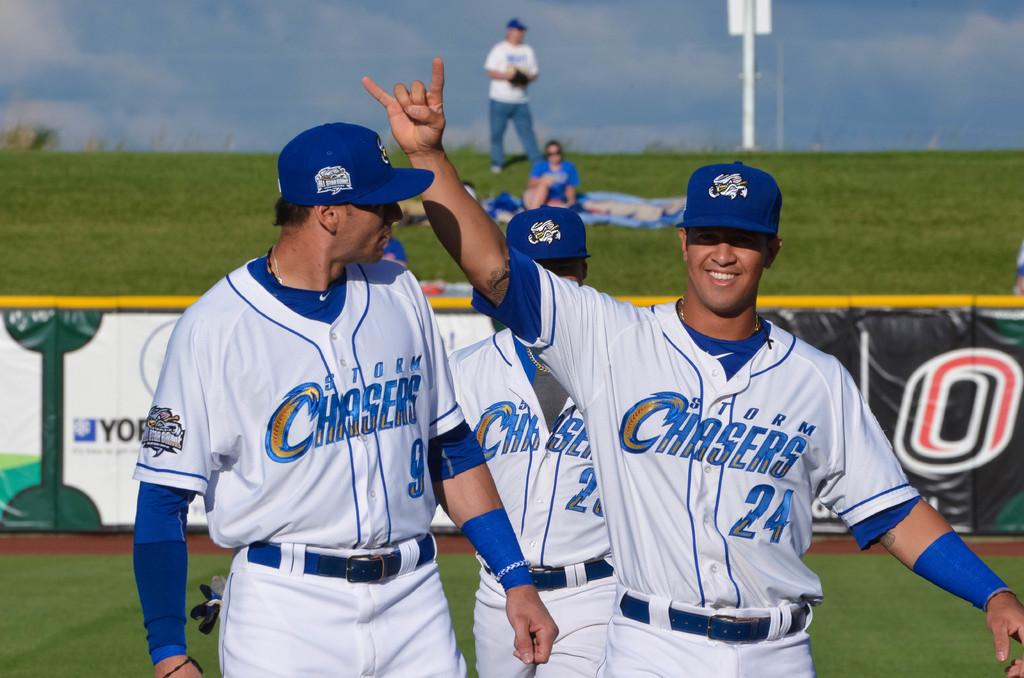<image>
Describe the image concisely. Three players, representing the Storm Chasers, pose for a picture on the field. 